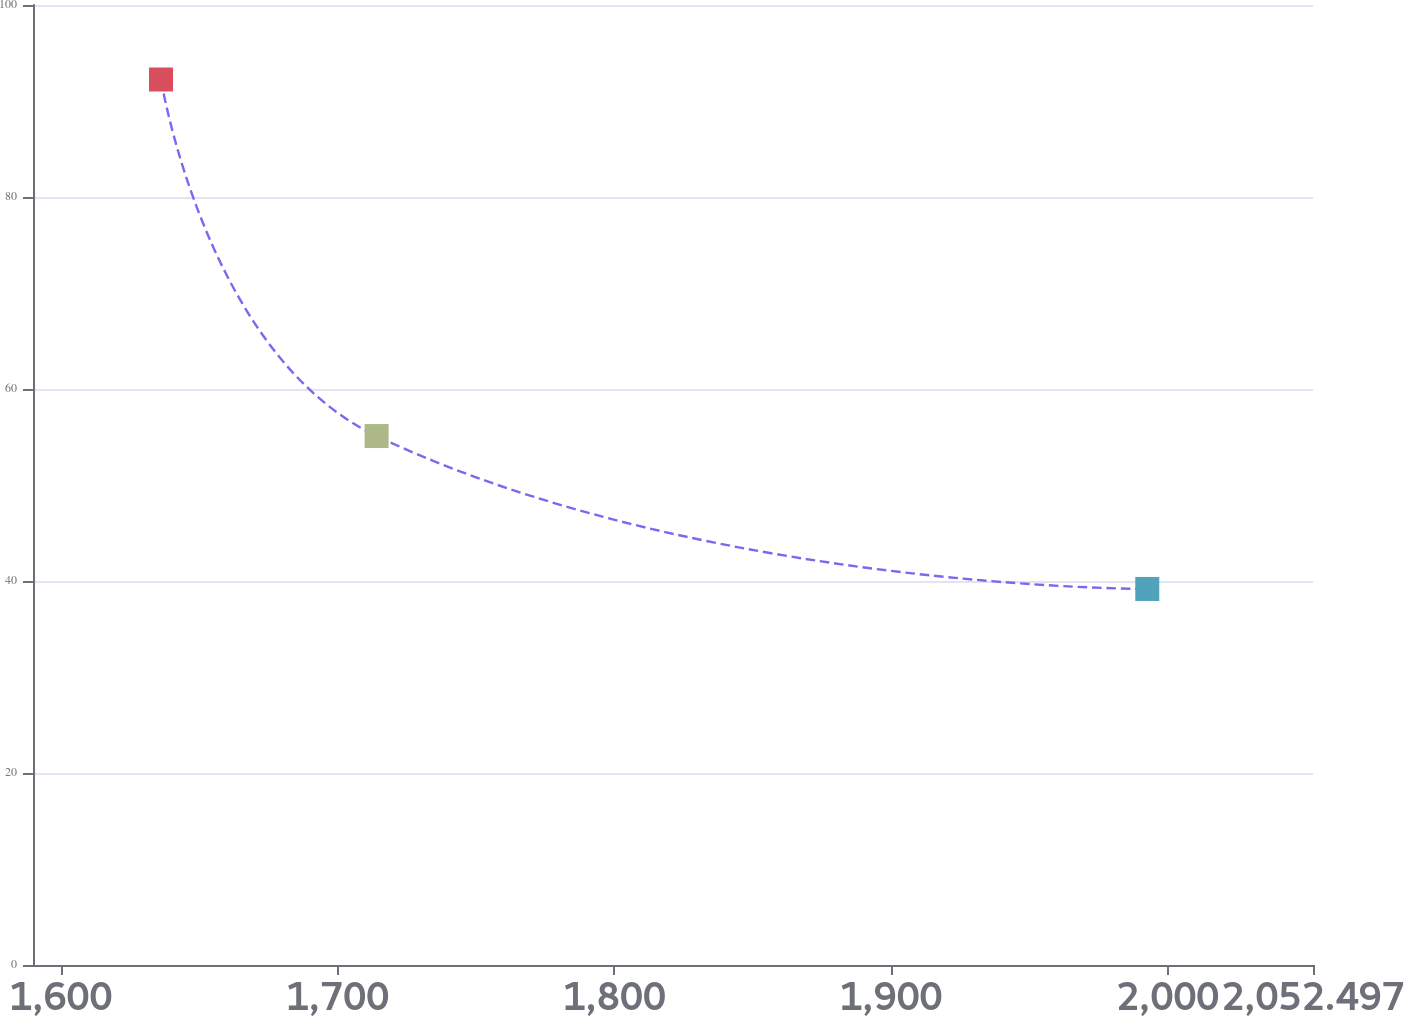<chart> <loc_0><loc_0><loc_500><loc_500><line_chart><ecel><fcel>Unnamed: 1<nl><fcel>1636.22<fcel>92.24<nl><fcel>1714.13<fcel>55.1<nl><fcel>1992.61<fcel>39.17<nl><fcel>2055.64<fcel>49.79<nl><fcel>2098.75<fcel>44.48<nl></chart> 